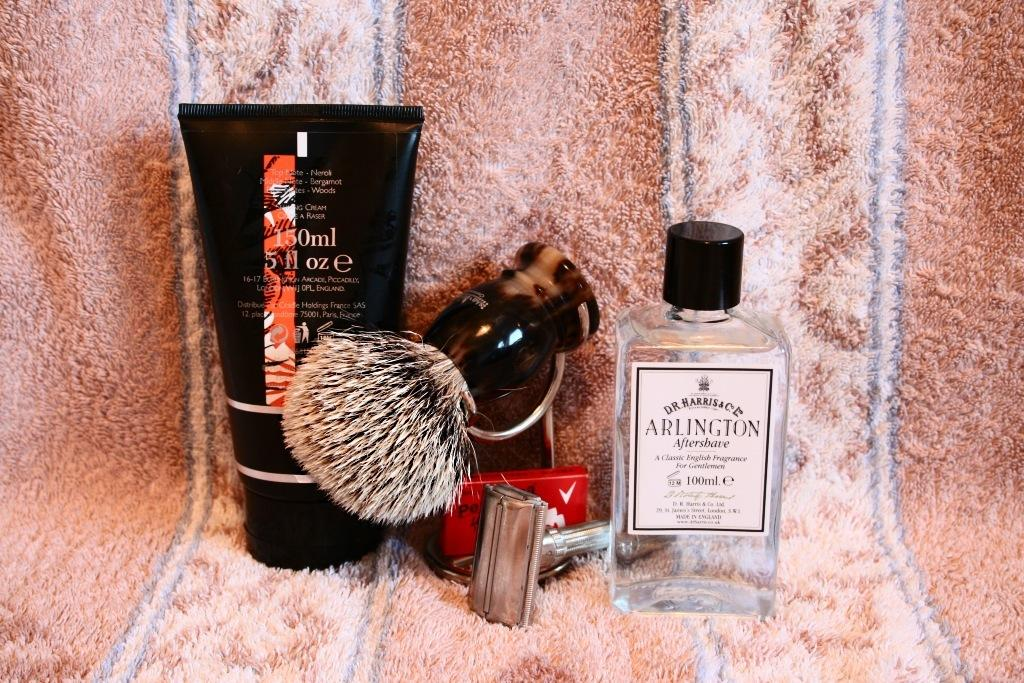Provide a one-sentence caption for the provided image. Men's shaving supplies with a bottle of Arlington aftershave. 